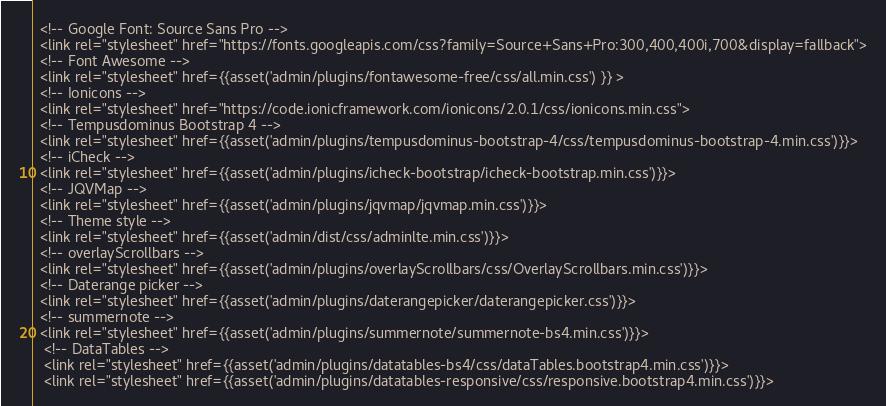Convert code to text. <code><loc_0><loc_0><loc_500><loc_500><_PHP_>
  <!-- Google Font: Source Sans Pro -->
  <link rel="stylesheet" href="https://fonts.googleapis.com/css?family=Source+Sans+Pro:300,400,400i,700&display=fallback">
  <!-- Font Awesome -->
  <link rel="stylesheet" href={{asset('admin/plugins/fontawesome-free/css/all.min.css') }} >
  <!-- Ionicons -->
  <link rel="stylesheet" href="https://code.ionicframework.com/ionicons/2.0.1/css/ionicons.min.css">
  <!-- Tempusdominus Bootstrap 4 -->
  <link rel="stylesheet" href={{asset('admin/plugins/tempusdominus-bootstrap-4/css/tempusdominus-bootstrap-4.min.css')}}>
  <!-- iCheck -->
  <link rel="stylesheet" href={{asset('admin/plugins/icheck-bootstrap/icheck-bootstrap.min.css')}}>
  <!-- JQVMap -->
  <link rel="stylesheet" href={{asset('admin/plugins/jqvmap/jqvmap.min.css')}}>
  <!-- Theme style -->
  <link rel="stylesheet" href={{asset('admin/dist/css/adminlte.min.css')}}>
  <!-- overlayScrollbars -->
  <link rel="stylesheet" href={{asset('admin/plugins/overlayScrollbars/css/OverlayScrollbars.min.css')}}>
  <!-- Daterange picker -->
  <link rel="stylesheet" href={{asset('admin/plugins/daterangepicker/daterangepicker.css')}}>
  <!-- summernote -->
  <link rel="stylesheet" href={{asset('admin/plugins/summernote/summernote-bs4.min.css')}}>
   <!-- DataTables -->
   <link rel="stylesheet" href={{asset('admin/plugins/datatables-bs4/css/dataTables.bootstrap4.min.css')}}>
   <link rel="stylesheet" href={{asset('admin/plugins/datatables-responsive/css/responsive.bootstrap4.min.css')}}></code> 